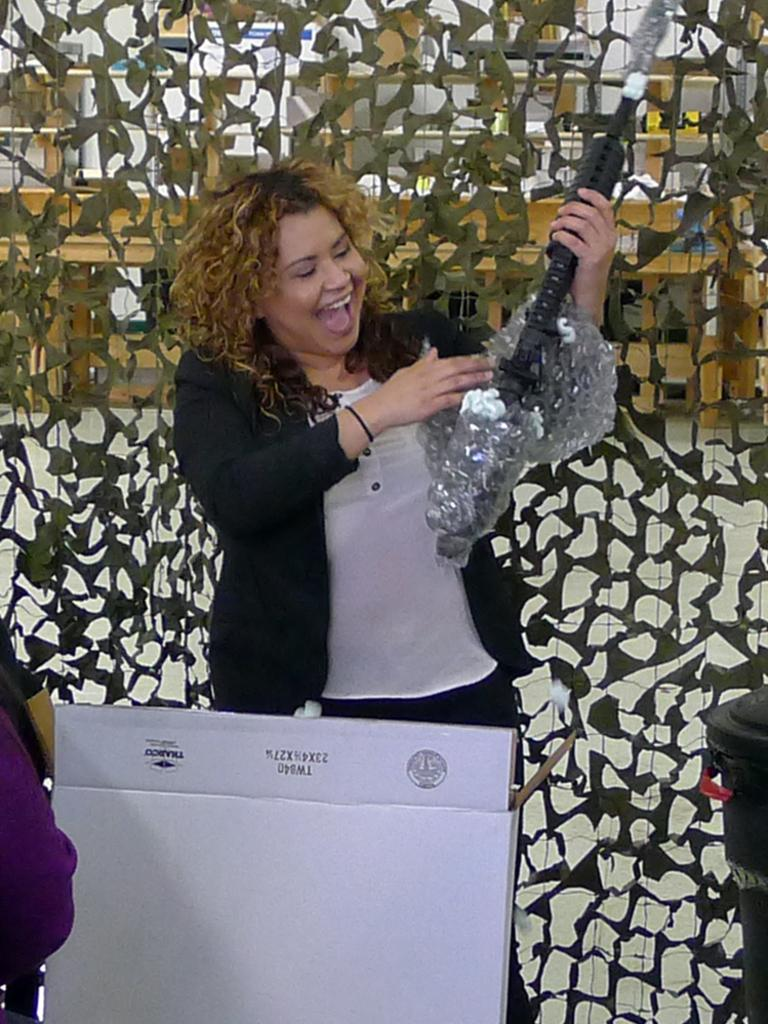What is the main subject of the image? There is a woman standing in the center of the image. What is the woman holding in the image? The woman is holding an object. What can be seen in the background of the image? There are decorations, cupboards, and a table in the background of the image. What type of letters can be seen on the tin in the image? There is no tin or letters present in the image. How does the woman's involvement in society affect the image? The image does not provide any information about the woman's involvement in society, so it cannot be determined how it affects the image. 